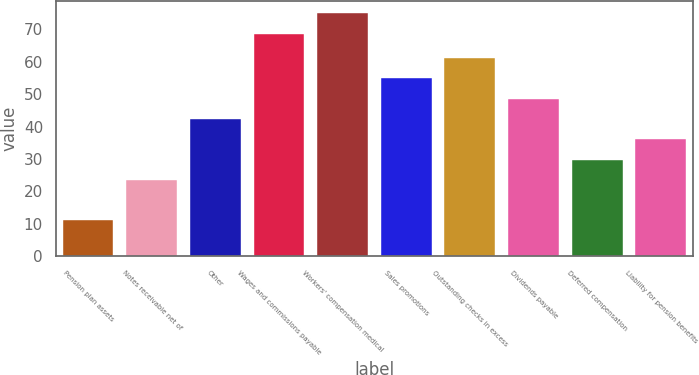Convert chart to OTSL. <chart><loc_0><loc_0><loc_500><loc_500><bar_chart><fcel>Pension plan assets<fcel>Notes receivable net of<fcel>Other<fcel>Wages and commissions payable<fcel>Workers' compensation medical<fcel>Sales promotions<fcel>Outstanding checks in excess<fcel>Dividends payable<fcel>Deferred compensation<fcel>Liability for pension benefits<nl><fcel>11<fcel>23.54<fcel>42.35<fcel>68.7<fcel>74.97<fcel>54.89<fcel>61.16<fcel>48.62<fcel>29.81<fcel>36.08<nl></chart> 